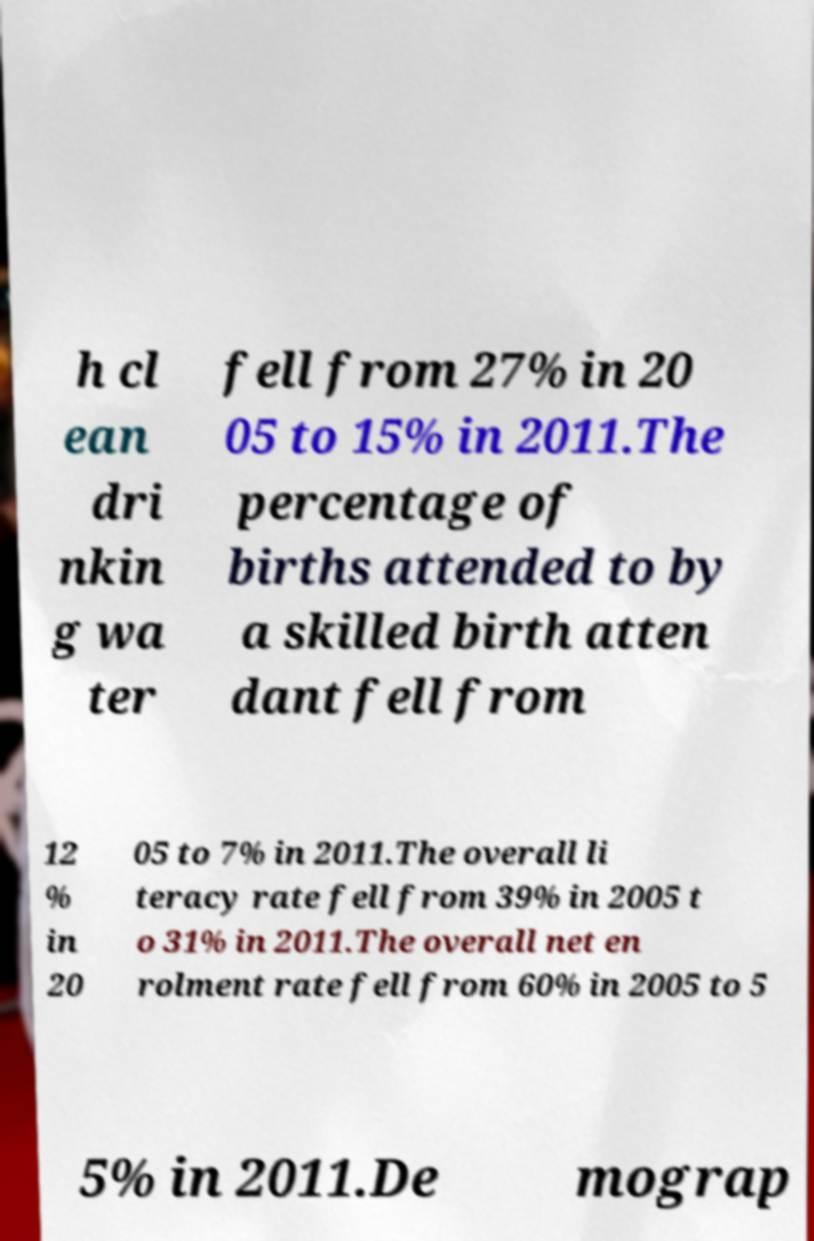Could you extract and type out the text from this image? h cl ean dri nkin g wa ter fell from 27% in 20 05 to 15% in 2011.The percentage of births attended to by a skilled birth atten dant fell from 12 % in 20 05 to 7% in 2011.The overall li teracy rate fell from 39% in 2005 t o 31% in 2011.The overall net en rolment rate fell from 60% in 2005 to 5 5% in 2011.De mograp 